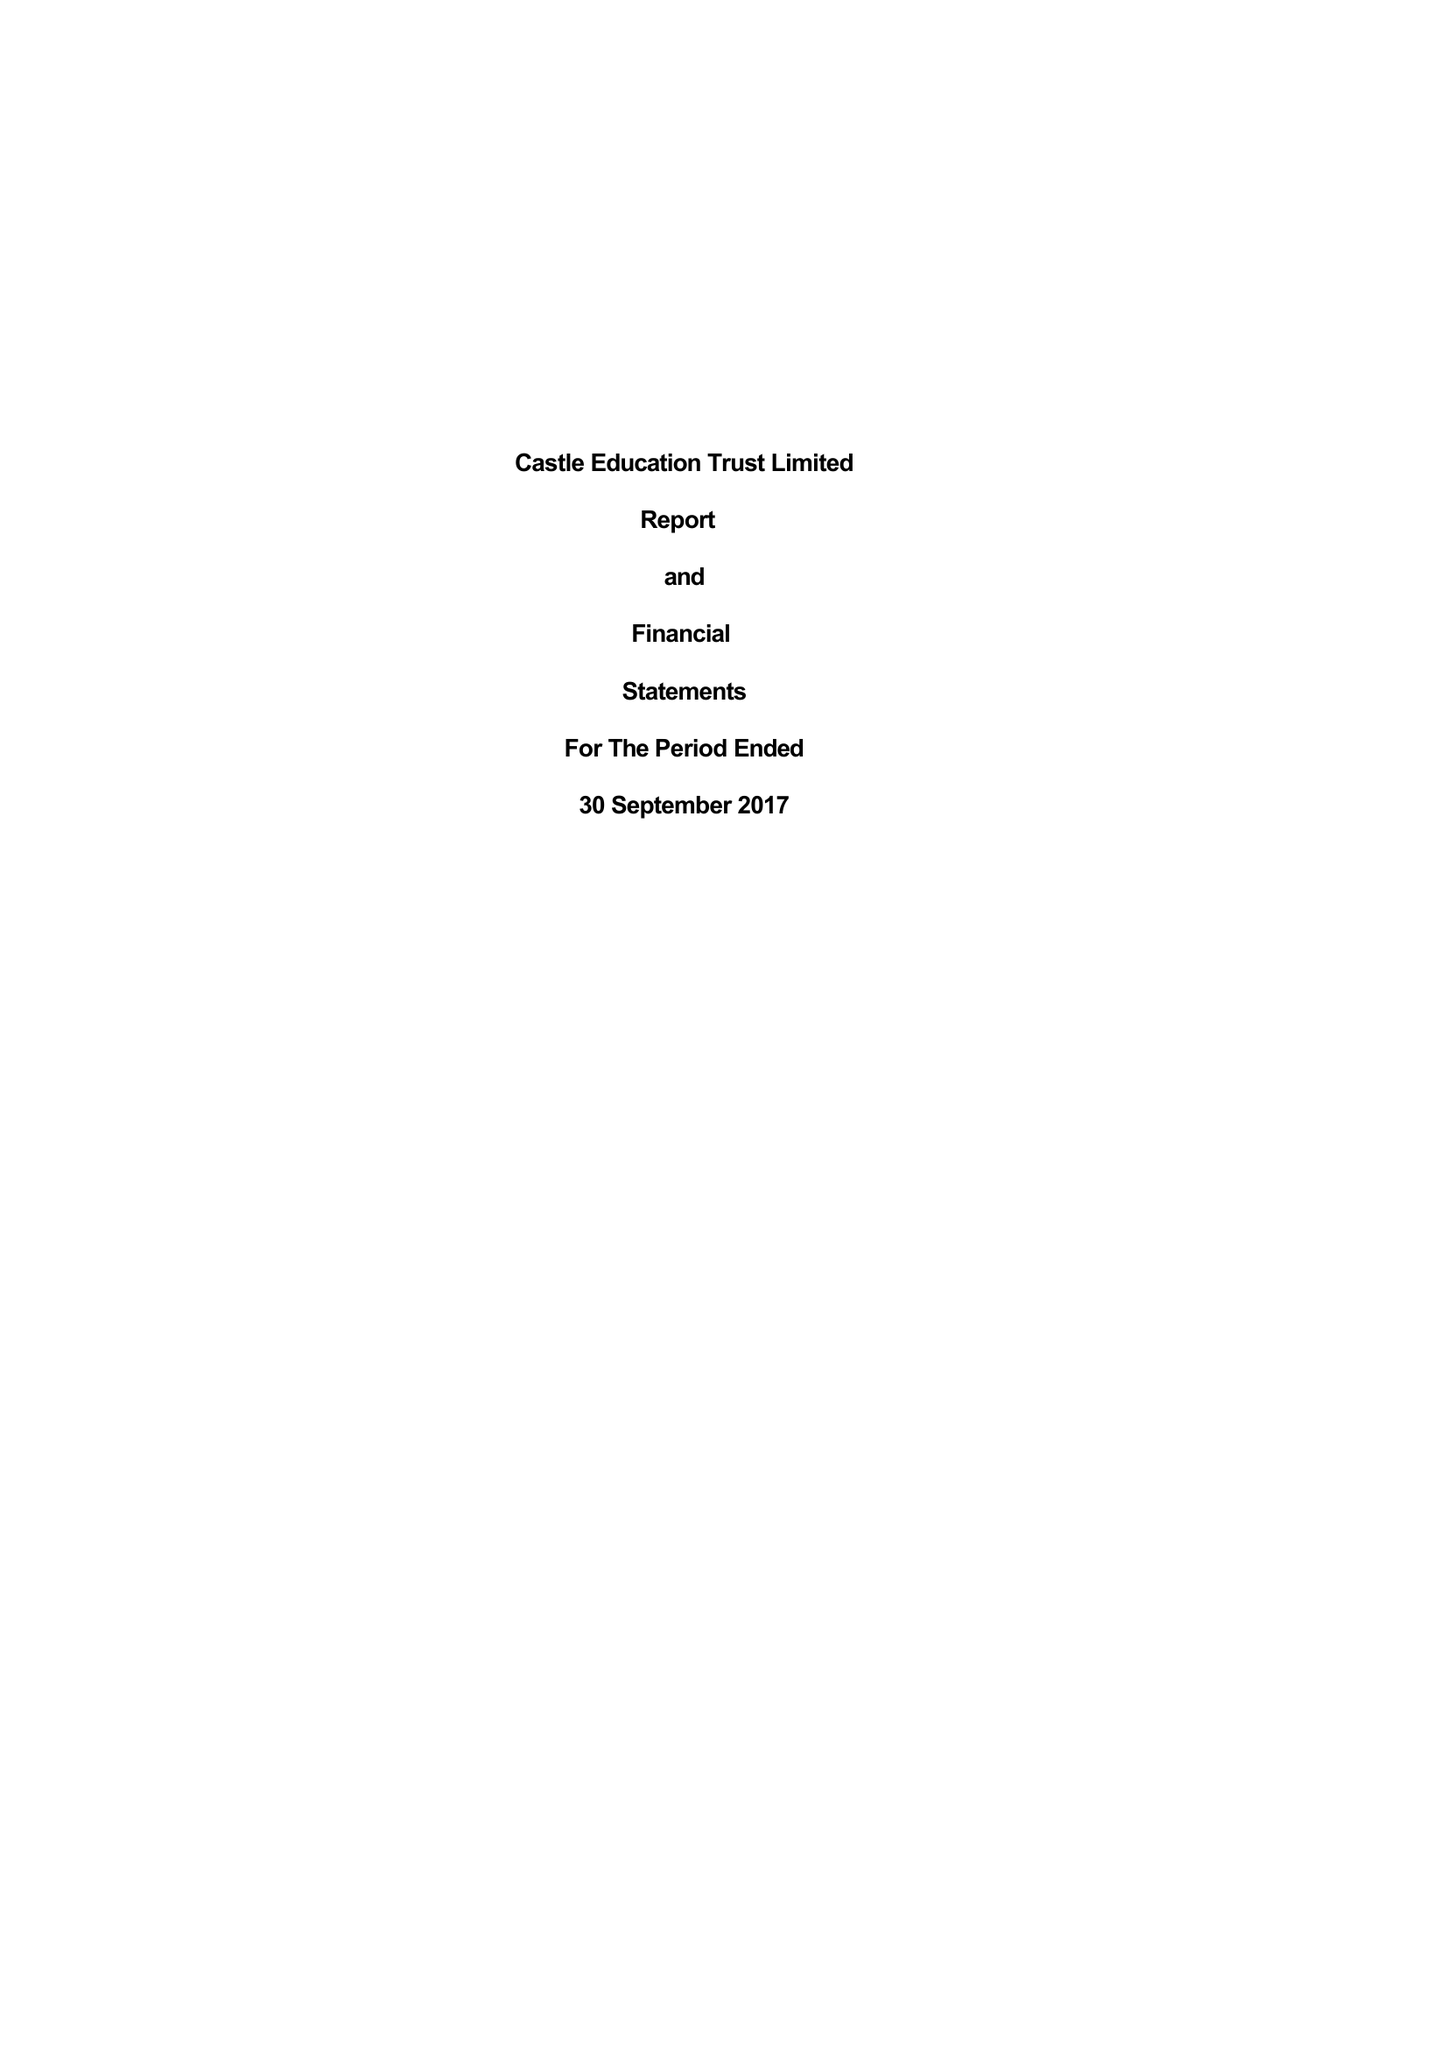What is the value for the spending_annually_in_british_pounds?
Answer the question using a single word or phrase. 30388.00 